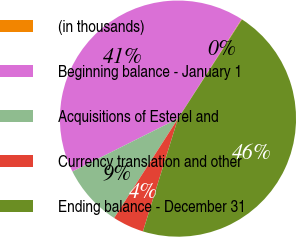<chart> <loc_0><loc_0><loc_500><loc_500><pie_chart><fcel>(in thousands)<fcel>Beginning balance - January 1<fcel>Acquisitions of Esterel and<fcel>Currency translation and other<fcel>Ending balance - December 31<nl><fcel>0.07%<fcel>41.45%<fcel>8.52%<fcel>4.29%<fcel>45.67%<nl></chart> 